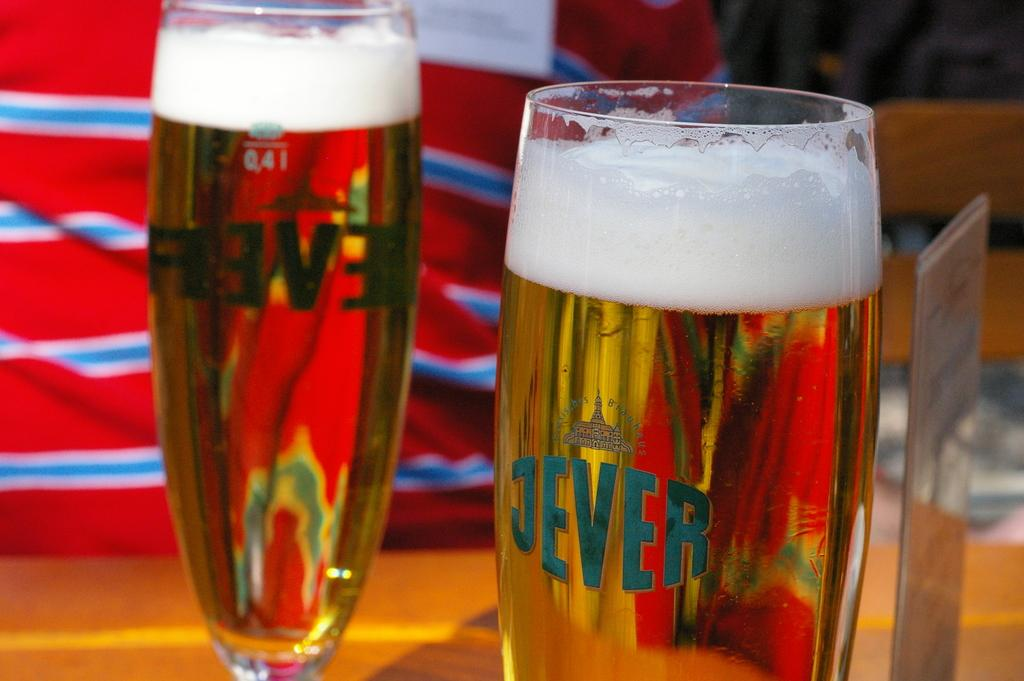Provide a one-sentence caption for the provided image. Two glasses of beer have the word Jever printed on them. 